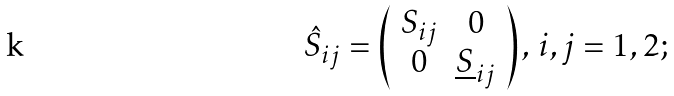<formula> <loc_0><loc_0><loc_500><loc_500>\hat { S } _ { i j } = \left ( \begin{array} { c c } S _ { i j } & 0 \\ 0 & \underline { S } _ { i j } \end{array} \right ) , \, i , j = 1 , 2 ;</formula> 